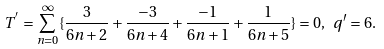Convert formula to latex. <formula><loc_0><loc_0><loc_500><loc_500>T ^ { ^ { \prime } } = \sum _ { n = 0 } ^ { \infty } \{ \frac { 3 } { 6 n + 2 } + \frac { - 3 } { 6 n + 4 } + \frac { - 1 } { 6 n + 1 } + \frac { 1 } { 6 n + 5 } \} = 0 , \ q ^ { \prime } = 6 .</formula> 